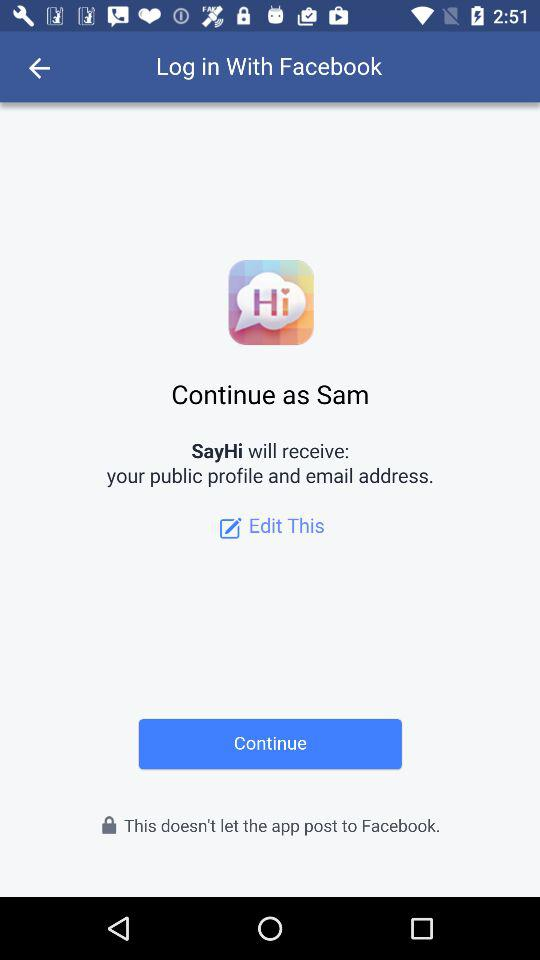Which application is used to log in? The application used to log in is "Facebook". 